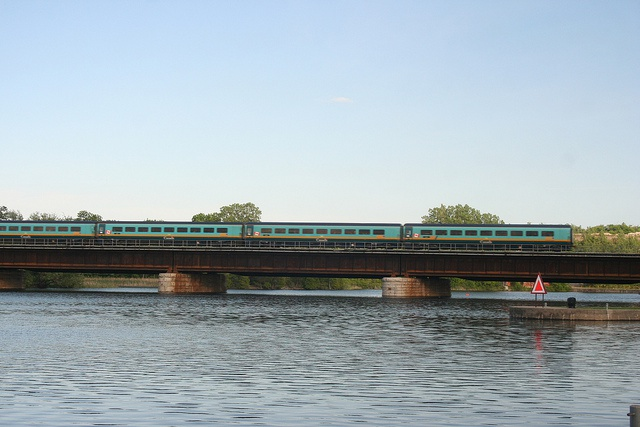Describe the objects in this image and their specific colors. I can see a train in lightblue, black, teal, gray, and darkblue tones in this image. 